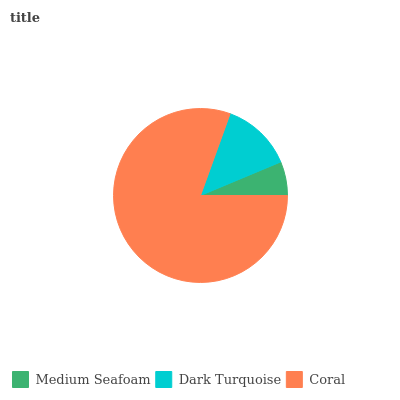Is Medium Seafoam the minimum?
Answer yes or no. Yes. Is Coral the maximum?
Answer yes or no. Yes. Is Dark Turquoise the minimum?
Answer yes or no. No. Is Dark Turquoise the maximum?
Answer yes or no. No. Is Dark Turquoise greater than Medium Seafoam?
Answer yes or no. Yes. Is Medium Seafoam less than Dark Turquoise?
Answer yes or no. Yes. Is Medium Seafoam greater than Dark Turquoise?
Answer yes or no. No. Is Dark Turquoise less than Medium Seafoam?
Answer yes or no. No. Is Dark Turquoise the high median?
Answer yes or no. Yes. Is Dark Turquoise the low median?
Answer yes or no. Yes. Is Coral the high median?
Answer yes or no. No. Is Medium Seafoam the low median?
Answer yes or no. No. 